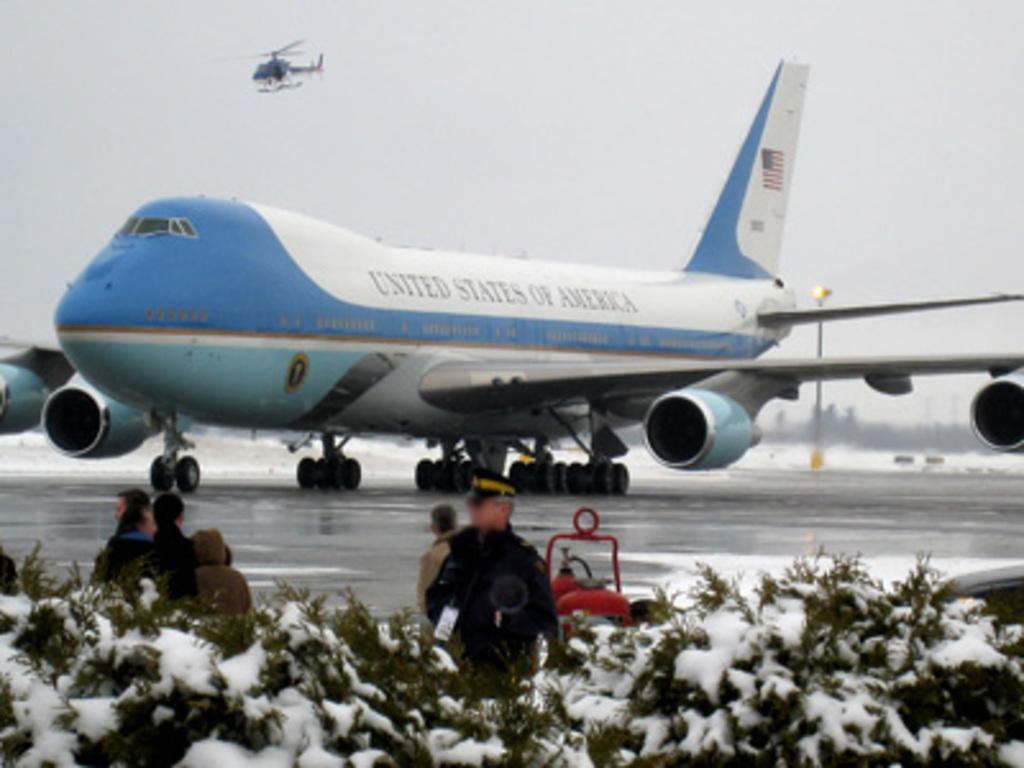Provide a one-sentence caption for the provided image. The United States of America Air Force 1 on the runway. 